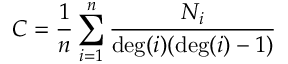<formula> <loc_0><loc_0><loc_500><loc_500>C = \frac { 1 } { n } \sum _ { i = 1 } ^ { n } \frac { N _ { i } } { \deg ( i ) ( \deg ( i ) - 1 ) }</formula> 